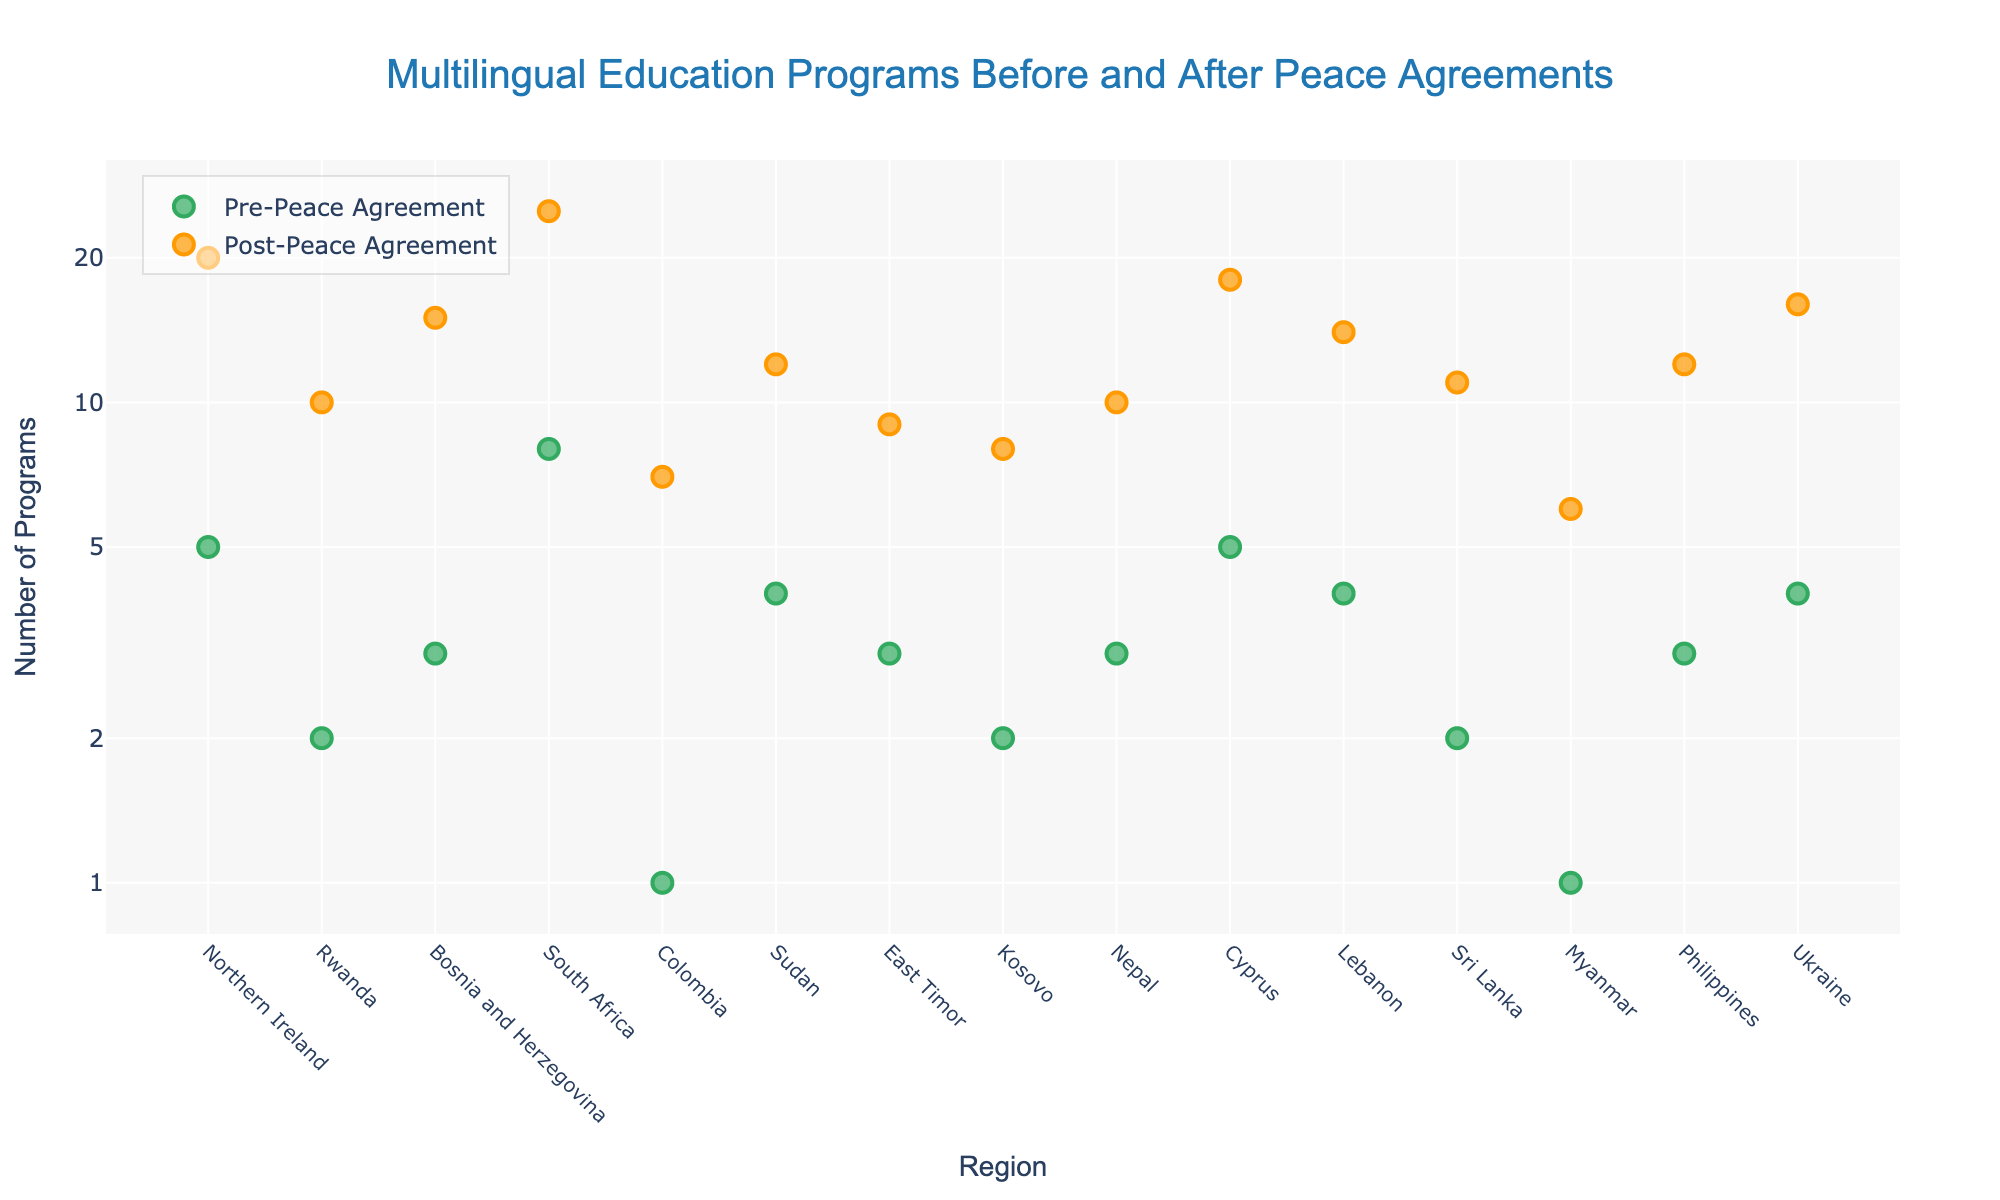What's the title of the figure? The title of the figure is displayed at the top and it reads "Multilingual Education Programs Before and After Peace Agreements".
Answer: Multilingual Education Programs Before and After Peace Agreements Which color represents post-peace agreement programs? Post-peace agreement programs are represented by orange markers, as indicated in the legend.
Answer: Orange What's the maximum number of programs implemented post-peace agreements according to the figure? The highest y-value for post-peace agreement programs is 25, which can be seen in the region of South Africa.
Answer: 25 How many regions implemented more than 10 multilingual education programs post-peace agreements? From the y-axis, we can count the regions with points above 10 in the orange markers. The regions are Northern Ireland, Rwanda, Bosnia and Herzegovina, South Africa, Cyprus, Lebanon, Philippines, and Ukraine.
Answer: 8 For which region did the number of multilingual education programs increase the most after the peace agreement? By inspecting the difference between the pre- and post-peace agreement values, South Africa increased the most from 8 to 25 programs.
Answer: South Africa What's the difference in the number of multilingual education programs before and after the peace agreements for Sudan? The number of programs pre-agreement is 4 and post-agreement is 12. So, the difference is 12 - 4.
Answer: 8 Which region has the closest number of multilingual education programs pre- and post-peace agreements? East Timor has 3 pre-agreement and 9 post-agreement, a difference of 6; the next smallest difference among regions is 7, so East Timor is the closest.
Answer: East Timor What is the sum of pre-peace agreement programs for Rwanda and Cyprus? The number of pre-peace agreement programs for Rwanda is 2 and for Cyprus is 5. Adding these together, 2 + 5.
Answer: 7 Comparing Northern Ireland and Bosnia and Herzegovina, which region saw a larger increase in multilingual education programs post-peace agreement? Northern Ireland increased from 5 to 20 programs (15 increase), and Bosnia and Herzegovina from 3 to 15 (12 increase). Therefore, Northern Ireland saw a larger increase.
Answer: Northern Ireland What's the log scale value closest to the number of multilingual education programs post-peace agreement for Kosovo? Kosovo post-peace agreement programs is 8. In log scale, 8 is closest to the log scale tick value of 10.
Answer: 10 